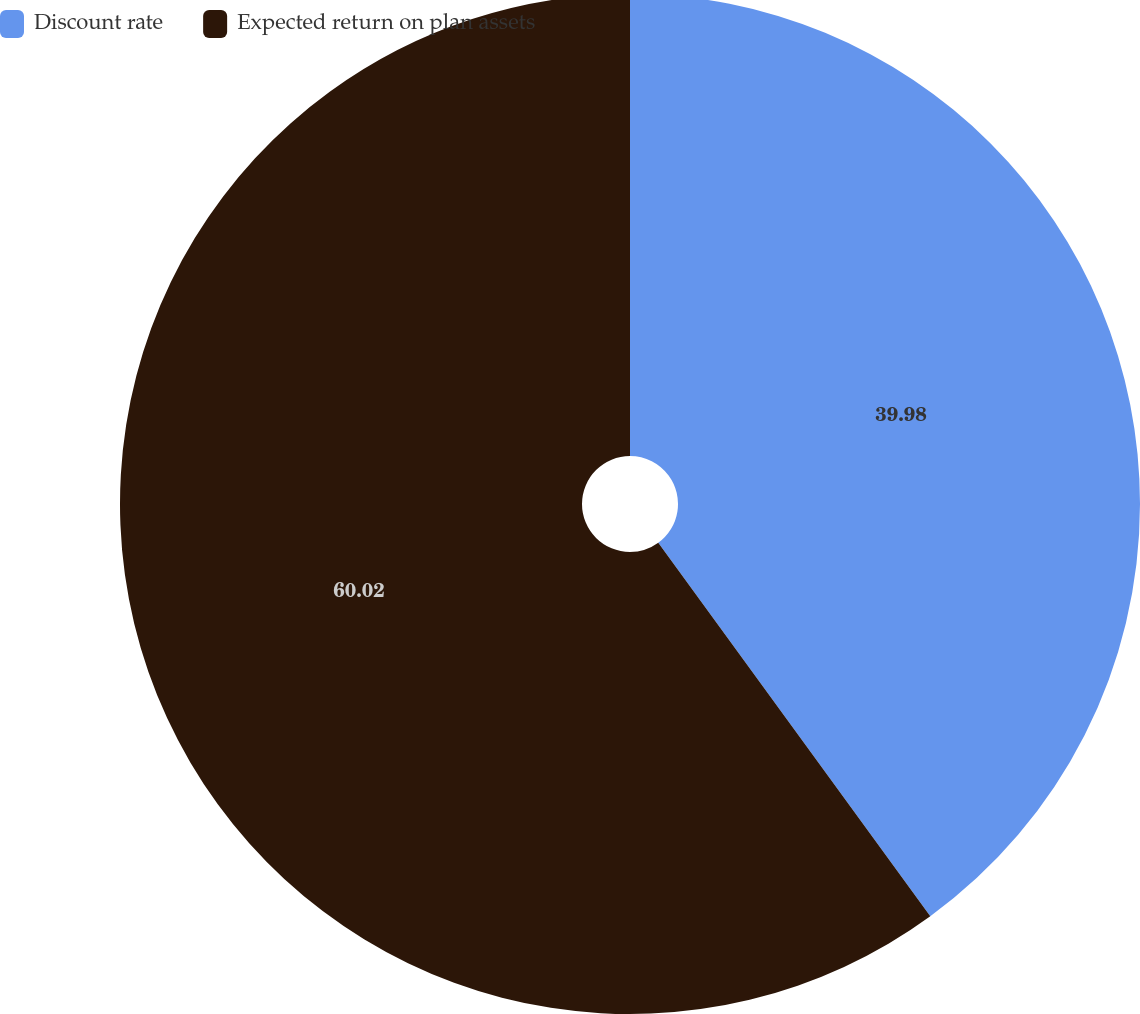Convert chart to OTSL. <chart><loc_0><loc_0><loc_500><loc_500><pie_chart><fcel>Discount rate<fcel>Expected return on plan assets<nl><fcel>39.98%<fcel>60.02%<nl></chart> 